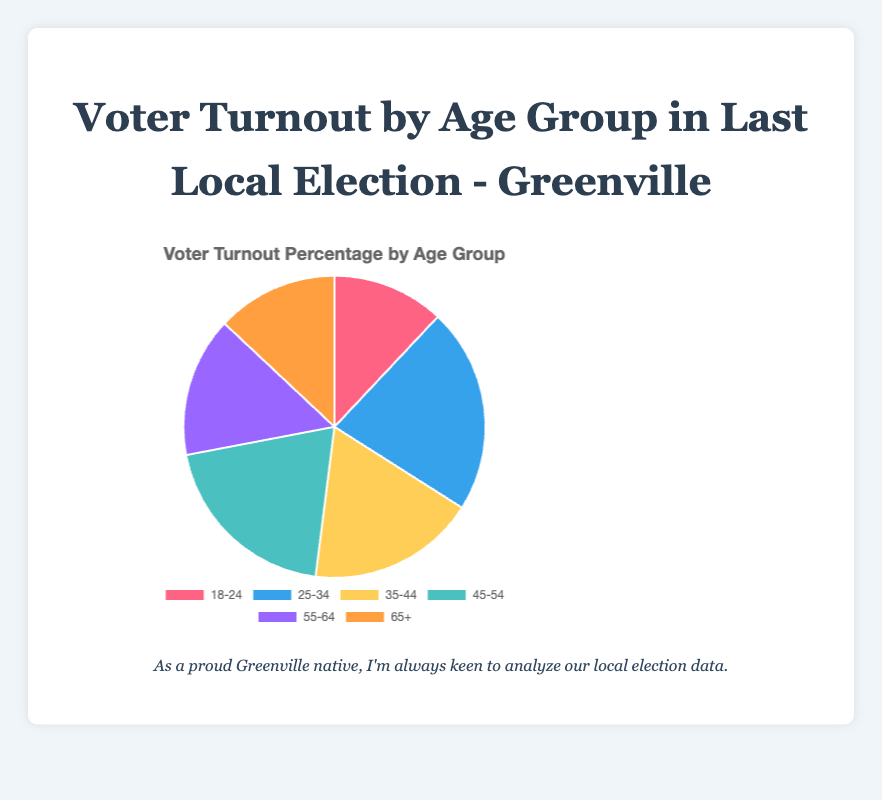what is the age group with the highest voter turnout percentage? The figure shows voter turnout percentages for various age groups. By comparing all values, we see that the "25-34" age group has the highest percentage at 22%.
Answer: 25-34 which age group has the lowest voter turnout percentage? By examining the chart, the "18-24" age group has the lowest voter turnout percentage, which is 12%.
Answer: 18-24 what's the difference in voter turnout percentage between the 25-34 and 65+ age groups? The "25-34" age group has a 22% voter turnout, and the "65+" age group has a 13% voter turnout. The difference is 22 - 13 = 9%.
Answer: 9% what is the combined voter turnout percentage for the 45-54 and 55-64 age groups? Voter turnout for the "45-54" age group is 20%, and for the "55-64" age group is 15%. Their combined voter turnout is 20 + 15 = 35%.
Answer: 35% how does the voter turnout for the 35-44 age group compare to the 18-24 age group? The "35-44" age group's voter turnout is 18%, while the "18-24" is 12%. Thus, the "35-44" group has a higher turnout by 6%.
Answer: 6% what is the average voter turnout percentage of all age groups? Sum all percentages: 12 + 22 + 18 + 20 + 15 + 13 = 100. There are 6 age groups, so the average is 100 / 6 ≈ 16.67%.
Answer: 16.67% what color is used to represent the 55-64 age group? The color for the "55-64" age group is identified as one of the slices on the pie chart. The figure uses shades of blue, red, yellow, green, purple, and orange. The specific color for "55-64" is identified as light purple.
Answer: light purple which age groups have voter turnout percentages greater than 18%? From the data, the age groups "25-34" with 22% and "45-54" with 20% have percentages greater than 18%.
Answer: 25-34 and 45-54 what is the total voter turnout percentage for all the age groups combined? The total voter turnout percentage is the sum of all provided percentages: 12 + 22 + 18 + 20 + 15 + 13 = 100%.
Answer: 100% which two age groups have the closest voter turnout percentages? By comparing the percentages, the "65+" and "18-24" age groups are closest with 13% and 12% respectively. The difference is just 1%.
Answer: 65+ and 18-24 